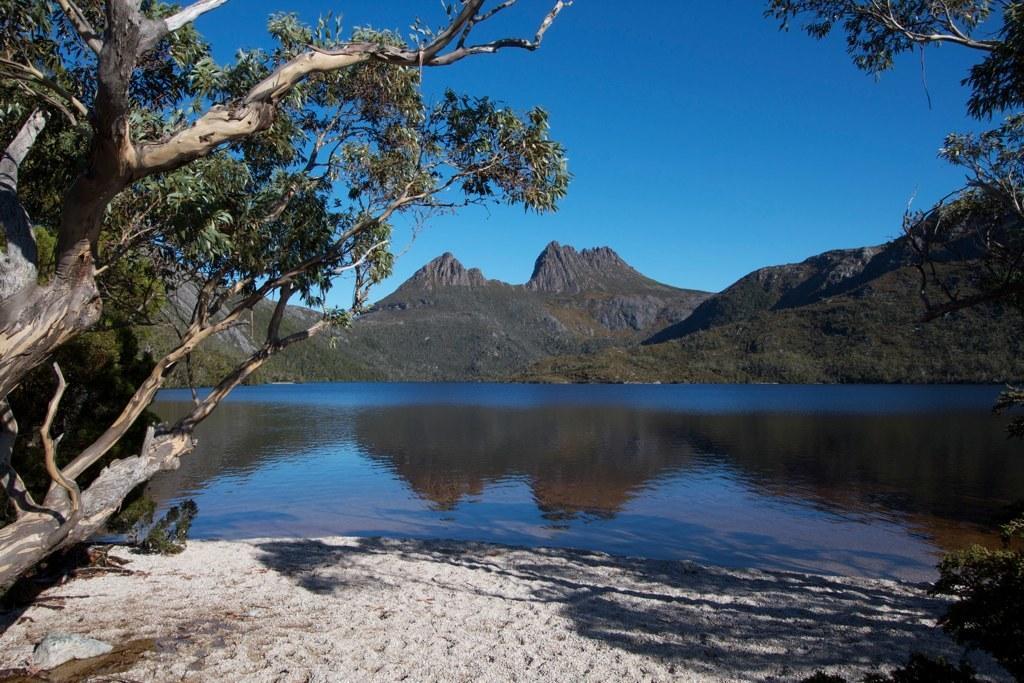Could you give a brief overview of what you see in this image? At the bottom of the image there are trees. In the center there is a river. In the background there are hills and sky. 